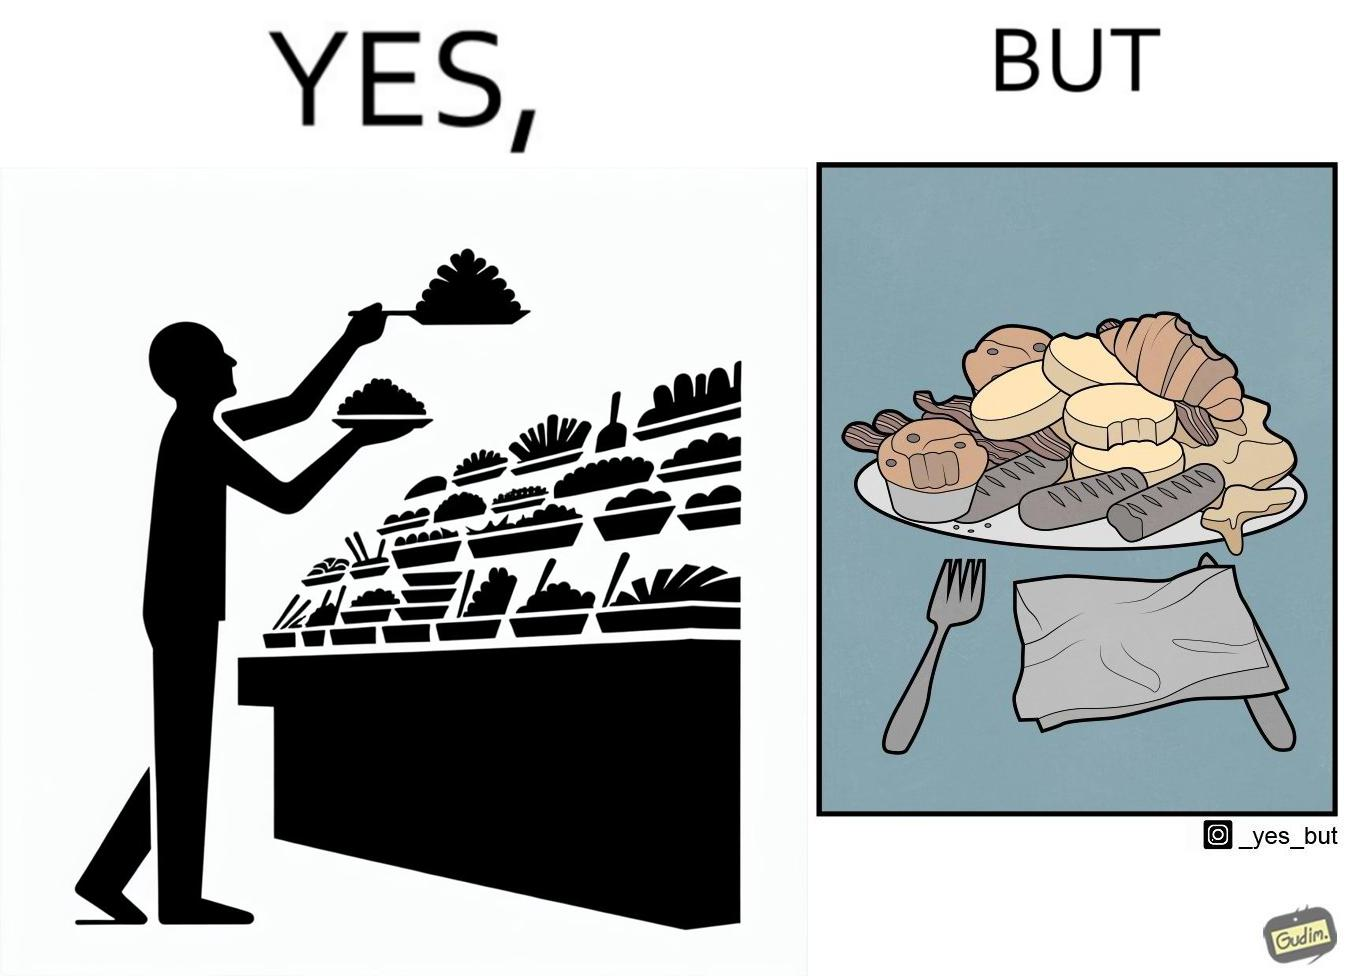What is shown in the left half versus the right half of this image? In the left part of the image: The image shows a man overfilling his plate with different kinds of food from a self serving station with various items placed on it. In the right part of the image: The image shows a plate full of food items. Most of the items seems untouched and few have been taken a bite from. 